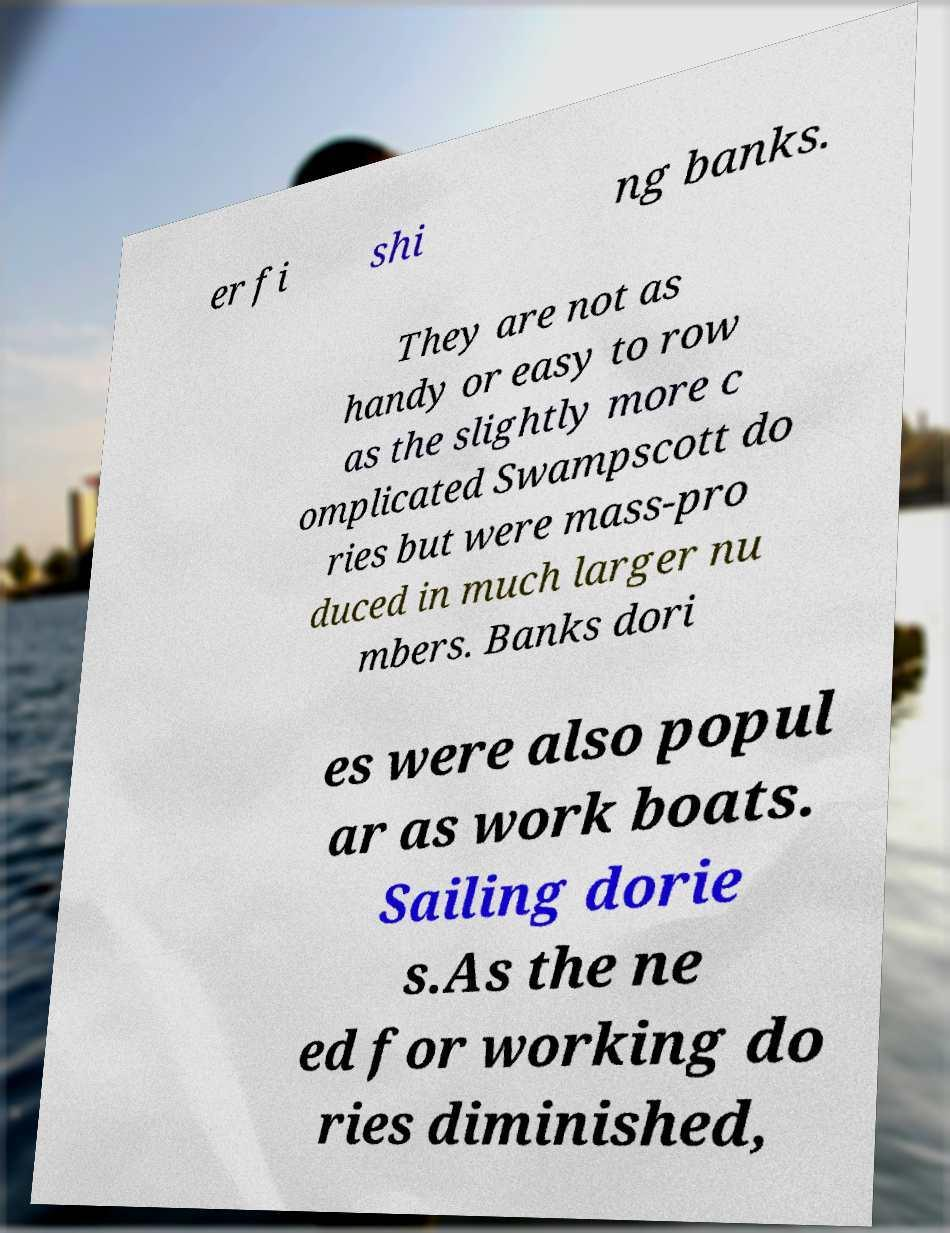Could you extract and type out the text from this image? er fi shi ng banks. They are not as handy or easy to row as the slightly more c omplicated Swampscott do ries but were mass-pro duced in much larger nu mbers. Banks dori es were also popul ar as work boats. Sailing dorie s.As the ne ed for working do ries diminished, 